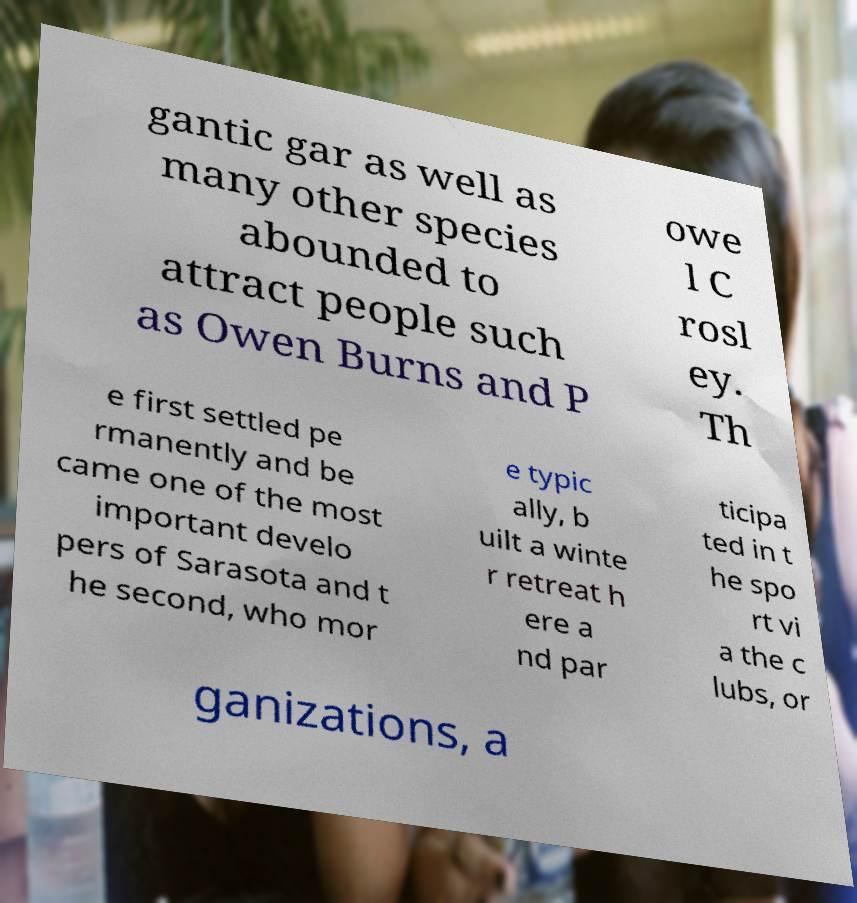I need the written content from this picture converted into text. Can you do that? gantic gar as well as many other species abounded to attract people such as Owen Burns and P owe l C rosl ey. Th e first settled pe rmanently and be came one of the most important develo pers of Sarasota and t he second, who mor e typic ally, b uilt a winte r retreat h ere a nd par ticipa ted in t he spo rt vi a the c lubs, or ganizations, a 